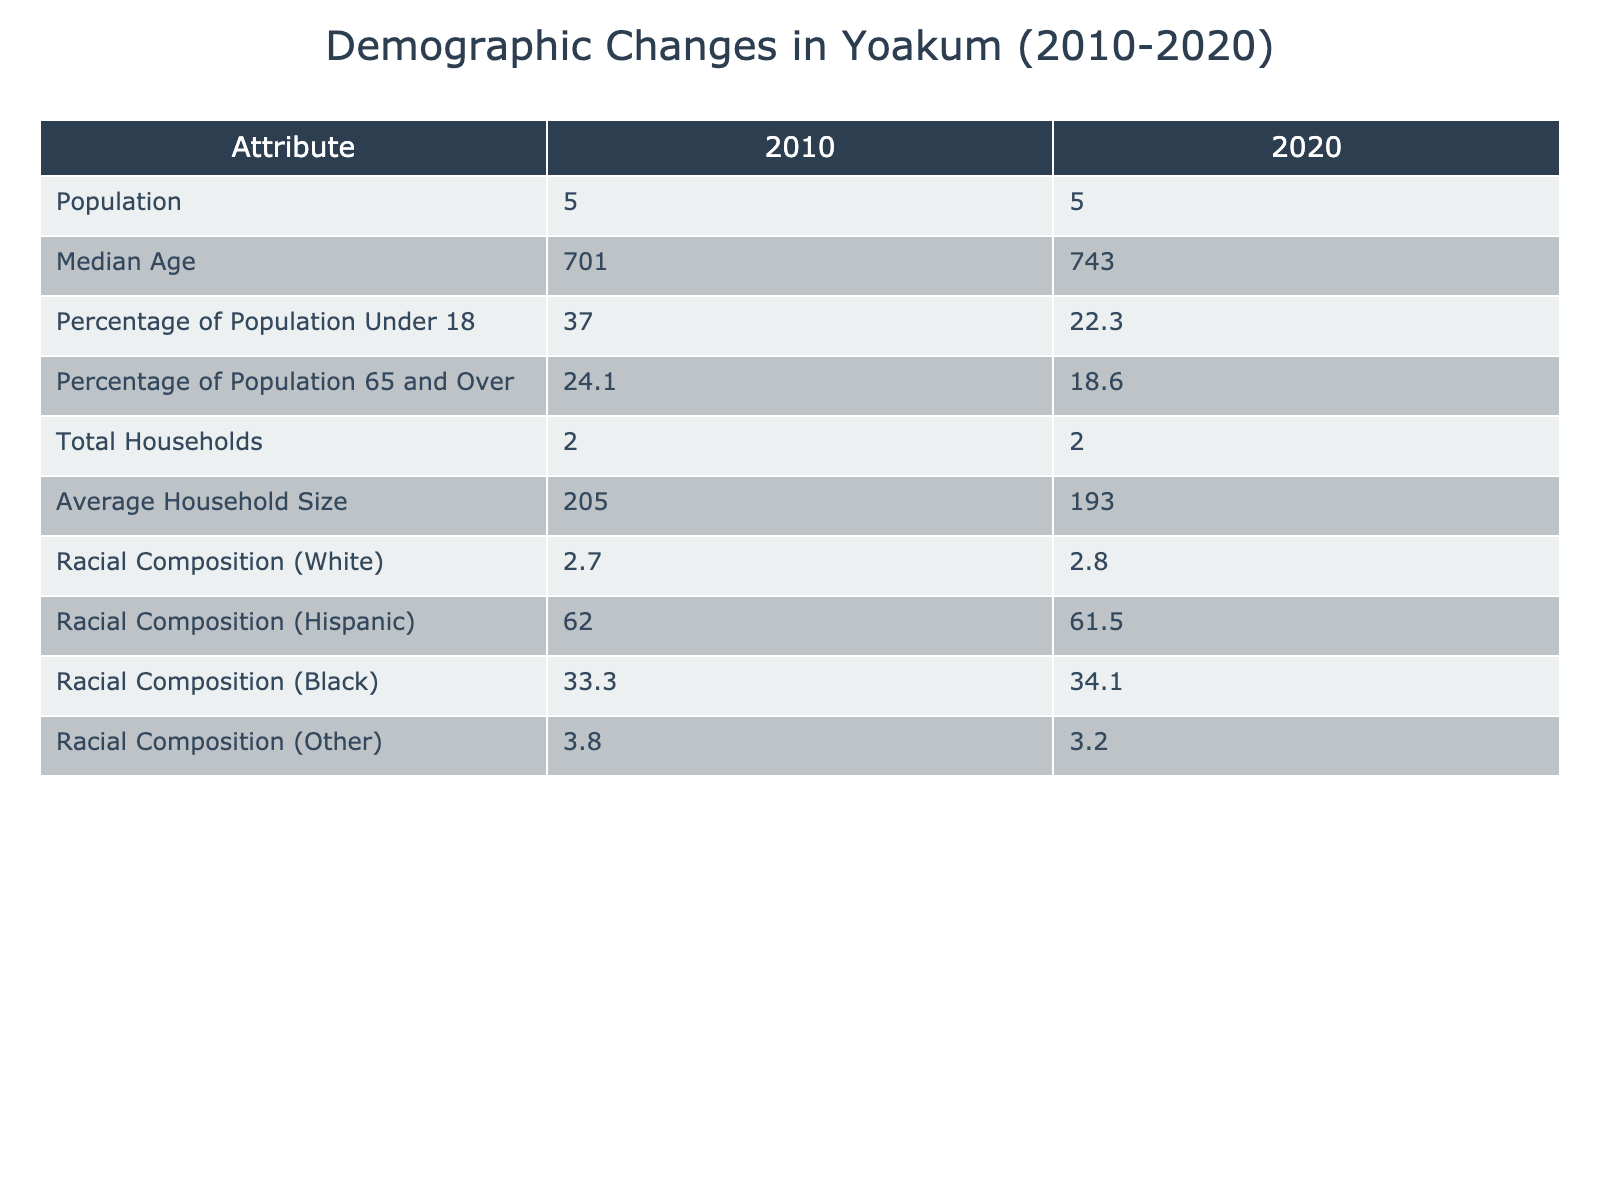What was the population of Yoakum in 2010? The table shows the population for the year 2010 as 5,701. Therefore, the population was 5,701 in that year.
Answer: 5,701 What percentage of the population was aged 65 and over in 2020? According to the table, 18.6% of the population was aged 65 and over in the year 2020.
Answer: 18.6% What is the difference in median age from 2010 to 2020? The median age in 2010 was 37.0, and in 2020 it was 22.3. The difference is calculated as 37.0 - 22.3 = 14.7.
Answer: 14.7 Did the percentage of the population under 18 increase from 2010 to 2020? In 2010, the percentage of the population under 18 was 24.1%, and in 2020 it was 22.3%. This shows a decrease, so the statement is false.
Answer: No What was the total number of households in 2020 and how does it compare to 2010? The total number of households in 2020 was 2,193. In 2010, it was 2,205. The comparison shows a decrease of 12 households from 2010 to 2020, as calculated by 2,205 - 2,193 = 12.
Answer: 2,193, decreased by 12 What was the average household size in Yoakum in 2020 compared to 2010? The average household size in 2010 was 2.7 and in 2020 it was 2.8. To compare, the increase is 2.8 - 2.7 = 0.1, indicating a slight increase in household size.
Answer: Increased by 0.1 What was the racial composition of Yoakum in 2020? The racial composition in 2020 included: 61.5% White, 34.1% Hispanic, 3.2% Black, and supplemented by the category 'Other'. These values represent the distribution of the population by race.
Answer: 61.5% White, 34.1% Hispanic, 3.2% Black Did the proportion of Hispanic residents increase from 2010 to 2020? The percentage of Hispanic residents in 2010 was 33.3% and increased to 34.1% in 2020. This indicates an increase in the proportion of Hispanic residents. Therefore, the statement is true.
Answer: Yes 